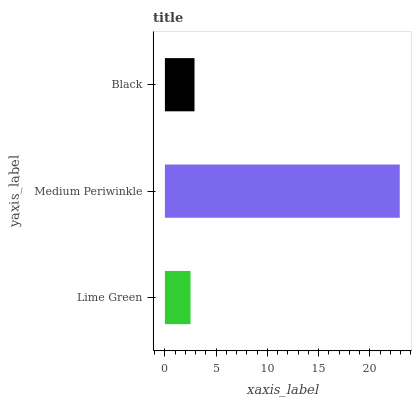Is Lime Green the minimum?
Answer yes or no. Yes. Is Medium Periwinkle the maximum?
Answer yes or no. Yes. Is Black the minimum?
Answer yes or no. No. Is Black the maximum?
Answer yes or no. No. Is Medium Periwinkle greater than Black?
Answer yes or no. Yes. Is Black less than Medium Periwinkle?
Answer yes or no. Yes. Is Black greater than Medium Periwinkle?
Answer yes or no. No. Is Medium Periwinkle less than Black?
Answer yes or no. No. Is Black the high median?
Answer yes or no. Yes. Is Black the low median?
Answer yes or no. Yes. Is Lime Green the high median?
Answer yes or no. No. Is Medium Periwinkle the low median?
Answer yes or no. No. 